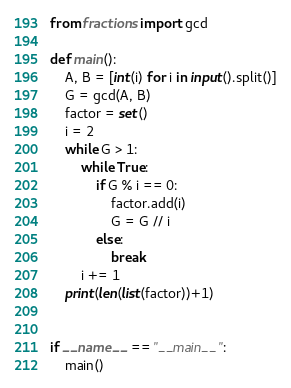Convert code to text. <code><loc_0><loc_0><loc_500><loc_500><_Python_>from fractions import gcd

def main():
    A, B = [int(i) for i in input().split()]
    G = gcd(A, B)
    factor = set()
    i = 2
    while G > 1:
        while True:
            if G % i == 0:
                factor.add(i)
                G = G // i
            else:
                break
        i += 1
    print(len(list(factor))+1)


if __name__ == "__main__":
    main()
</code> 